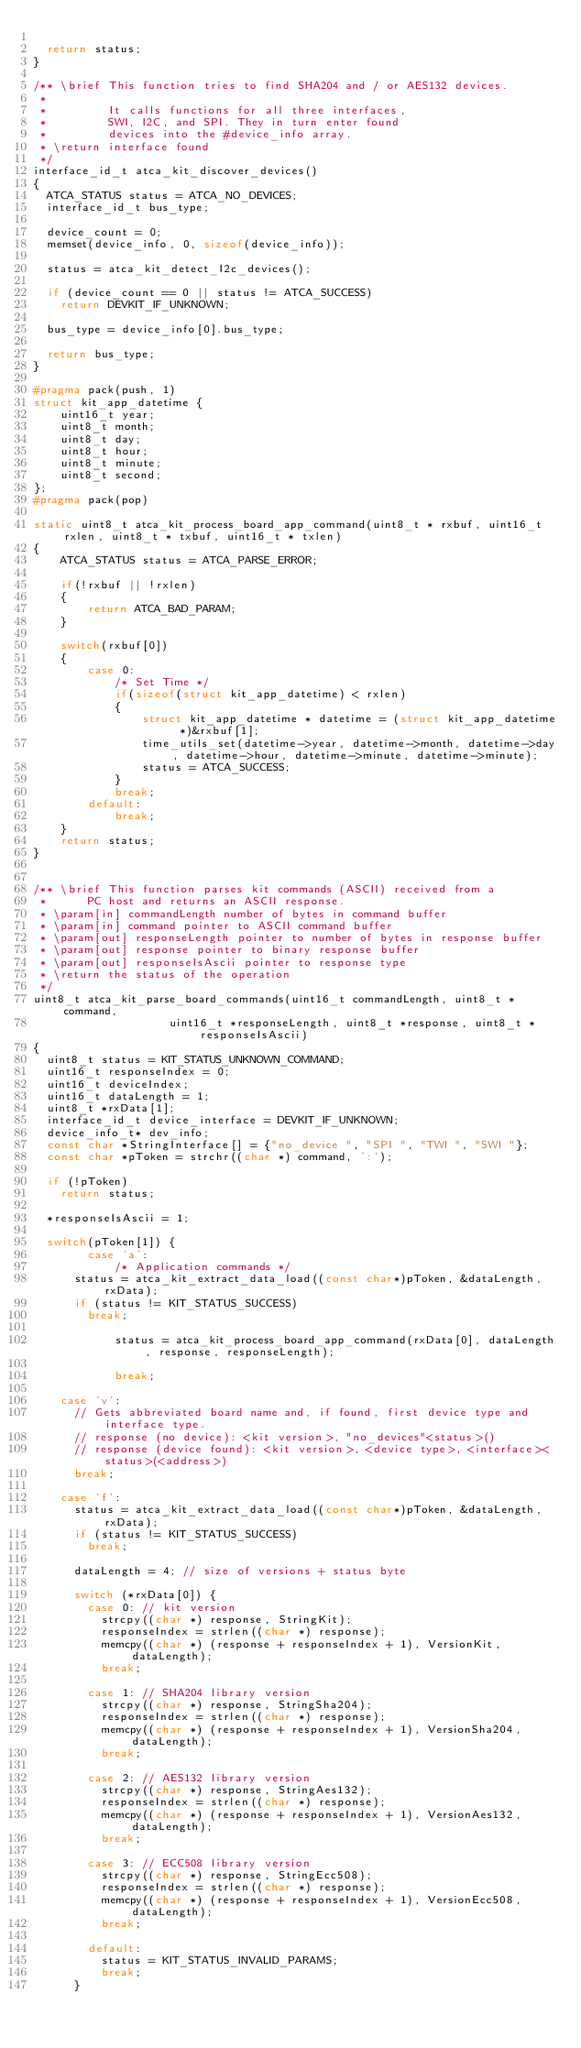Convert code to text. <code><loc_0><loc_0><loc_500><loc_500><_C_>	
	return status;
}

/** \brief This function tries to find SHA204 and / or AES132 devices.
 *
 *         It calls functions for all three interfaces,
 *         SWI, I2C, and SPI. They in turn enter found
 *         devices into the #device_info array.
 * \return interface found
 */
interface_id_t atca_kit_discover_devices()
{
	ATCA_STATUS status = ATCA_NO_DEVICES;
	interface_id_t bus_type;

	device_count = 0;
	memset(device_info, 0, sizeof(device_info));

	status = atca_kit_detect_I2c_devices();

	if (device_count == 0 || status != ATCA_SUCCESS)
		return DEVKIT_IF_UNKNOWN;

	bus_type = device_info[0].bus_type;

	return bus_type;
}

#pragma pack(push, 1)
struct kit_app_datetime {
    uint16_t year;
    uint8_t month;
    uint8_t day;
    uint8_t hour;
    uint8_t minute;
    uint8_t second;
};
#pragma pack(pop)

static uint8_t atca_kit_process_board_app_command(uint8_t * rxbuf, uint16_t rxlen, uint8_t * txbuf, uint16_t * txlen)
{
    ATCA_STATUS status = ATCA_PARSE_ERROR;

    if(!rxbuf || !rxlen)
    {
        return ATCA_BAD_PARAM;
    }

    switch(rxbuf[0])
    {
        case 0:
            /* Set Time */
            if(sizeof(struct kit_app_datetime) < rxlen)
            {
                struct kit_app_datetime * datetime = (struct kit_app_datetime *)&rxbuf[1];
                time_utils_set(datetime->year, datetime->month, datetime->day, datetime->hour, datetime->minute, datetime->minute);
                status = ATCA_SUCCESS;
            }
            break;
        default:
            break;
    }
    return status;
}


/** \brief This function parses kit commands (ASCII) received from a
 * 			PC host and returns an ASCII response.
 * \param[in] commandLength number of bytes in command buffer
 * \param[in] command pointer to ASCII command buffer
 * \param[out] responseLength pointer to number of bytes in response buffer
 * \param[out] response pointer to binary response buffer
 * \param[out] responseIsAscii pointer to response type
 * \return the status of the operation
 */
uint8_t atca_kit_parse_board_commands(uint16_t commandLength, uint8_t *command, 
										uint16_t *responseLength, uint8_t *response, uint8_t *responseIsAscii)
{
	uint8_t status = KIT_STATUS_UNKNOWN_COMMAND;
	uint16_t responseIndex = 0;
	uint16_t deviceIndex;
	uint16_t dataLength = 1;
	uint8_t *rxData[1];
	interface_id_t device_interface = DEVKIT_IF_UNKNOWN;
	device_info_t* dev_info;
	const char *StringInterface[] = {"no_device ", "SPI ", "TWI ", "SWI "};
	const char *pToken = strchr((char *) command, ':');

	if (!pToken)
		return status;

	*responseIsAscii = 1;

	switch(pToken[1]) {
        case 'a':
            /* Application commands */
			status = atca_kit_extract_data_load((const char*)pToken, &dataLength, rxData);
			if (status != KIT_STATUS_SUCCESS)
				break;

            status = atca_kit_process_board_app_command(rxData[0], dataLength, response, responseLength);

            break;

		case 'v':
			// Gets abbreviated board name and, if found, first device type and interface type.
			// response (no device): <kit version>, "no_devices"<status>()
			// response (device found): <kit version>, <device type>, <interface><status>(<address>)			
			break;
		
		case 'f':
			status = atca_kit_extract_data_load((const char*)pToken, &dataLength, rxData);
			if (status != KIT_STATUS_SUCCESS)
				break;

			dataLength = 4; // size of versions + status byte

			switch (*rxData[0]) {
				case 0: // kit version
					strcpy((char *) response, StringKit);
					responseIndex = strlen((char *) response);
					memcpy((char *) (response + responseIndex + 1), VersionKit, dataLength);
					break;

				case 1: // SHA204 library version
					strcpy((char *) response, StringSha204);
					responseIndex = strlen((char *) response);
					memcpy((char *) (response + responseIndex + 1), VersionSha204, dataLength);
					break;

				case 2: // AES132 library version
					strcpy((char *) response, StringAes132);
					responseIndex = strlen((char *) response);
					memcpy((char *) (response + responseIndex + 1), VersionAes132, dataLength);
					break;

				case 3: // ECC508 library version
					strcpy((char *) response, StringEcc508);
					responseIndex = strlen((char *) response);
					memcpy((char *) (response + responseIndex + 1), VersionEcc508, dataLength);
					break;

				default:
					status = KIT_STATUS_INVALID_PARAMS;
					break;
			}</code> 